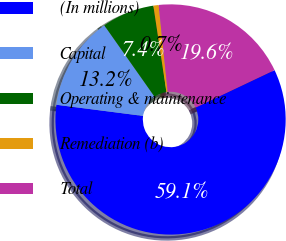Convert chart to OTSL. <chart><loc_0><loc_0><loc_500><loc_500><pie_chart><fcel>(In millions)<fcel>Capital<fcel>Operating & maintenance<fcel>Remediation (b)<fcel>Total<nl><fcel>59.09%<fcel>13.2%<fcel>7.37%<fcel>0.74%<fcel>19.6%<nl></chart> 